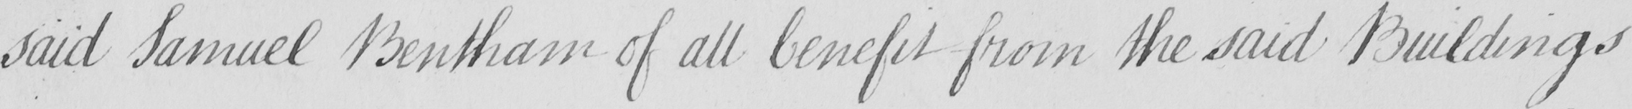Please provide the text content of this handwritten line. said Samuel Bentham of all benefit from the said Buildings 